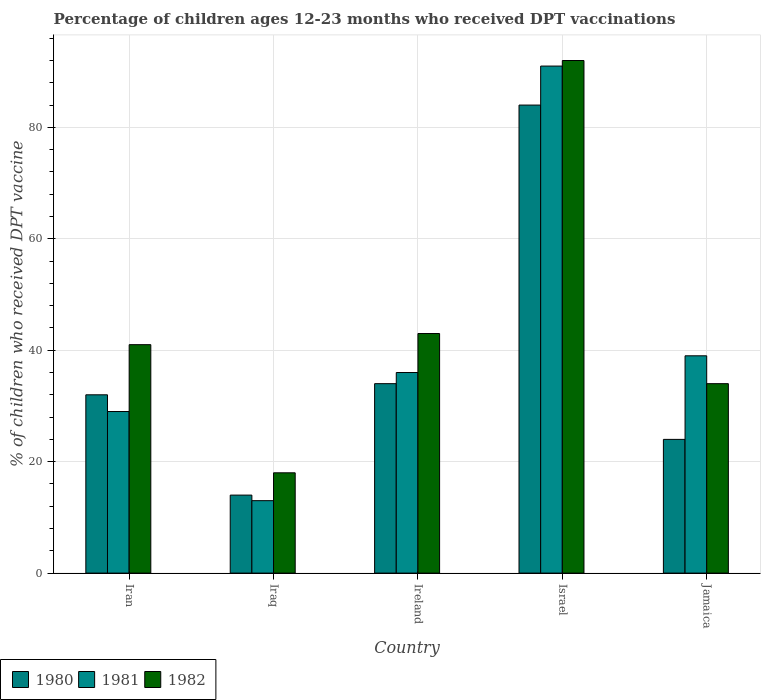Are the number of bars on each tick of the X-axis equal?
Provide a short and direct response. Yes. How many bars are there on the 3rd tick from the left?
Keep it short and to the point. 3. How many bars are there on the 4th tick from the right?
Offer a very short reply. 3. What is the label of the 4th group of bars from the left?
Your answer should be very brief. Israel. Across all countries, what is the maximum percentage of children who received DPT vaccination in 1981?
Offer a very short reply. 91. In which country was the percentage of children who received DPT vaccination in 1982 minimum?
Your answer should be very brief. Iraq. What is the total percentage of children who received DPT vaccination in 1980 in the graph?
Ensure brevity in your answer.  188. What is the difference between the percentage of children who received DPT vaccination in 1982 in Israel and that in Jamaica?
Provide a short and direct response. 58. What is the difference between the percentage of children who received DPT vaccination in 1981 in Jamaica and the percentage of children who received DPT vaccination in 1982 in Iraq?
Provide a succinct answer. 21. What is the average percentage of children who received DPT vaccination in 1980 per country?
Make the answer very short. 37.6. In how many countries, is the percentage of children who received DPT vaccination in 1981 greater than 28 %?
Your response must be concise. 4. What is the ratio of the percentage of children who received DPT vaccination in 1982 in Israel to that in Jamaica?
Ensure brevity in your answer.  2.71. Is the percentage of children who received DPT vaccination in 1982 in Iran less than that in Israel?
Offer a very short reply. Yes. What is the difference between the highest and the second highest percentage of children who received DPT vaccination in 1982?
Give a very brief answer. -2. What is the difference between the highest and the lowest percentage of children who received DPT vaccination in 1981?
Give a very brief answer. 78. Is the sum of the percentage of children who received DPT vaccination in 1982 in Iran and Jamaica greater than the maximum percentage of children who received DPT vaccination in 1981 across all countries?
Your response must be concise. No. What does the 3rd bar from the left in Iran represents?
Your answer should be compact. 1982. Are all the bars in the graph horizontal?
Give a very brief answer. No. What is the difference between two consecutive major ticks on the Y-axis?
Ensure brevity in your answer.  20. Are the values on the major ticks of Y-axis written in scientific E-notation?
Provide a short and direct response. No. Does the graph contain any zero values?
Make the answer very short. No. Does the graph contain grids?
Offer a very short reply. Yes. What is the title of the graph?
Offer a terse response. Percentage of children ages 12-23 months who received DPT vaccinations. Does "1966" appear as one of the legend labels in the graph?
Ensure brevity in your answer.  No. What is the label or title of the X-axis?
Offer a very short reply. Country. What is the label or title of the Y-axis?
Your answer should be very brief. % of children who received DPT vaccine. What is the % of children who received DPT vaccine of 1980 in Iran?
Provide a short and direct response. 32. What is the % of children who received DPT vaccine in 1981 in Iran?
Give a very brief answer. 29. What is the % of children who received DPT vaccine of 1980 in Iraq?
Offer a very short reply. 14. What is the % of children who received DPT vaccine of 1981 in Iraq?
Offer a very short reply. 13. What is the % of children who received DPT vaccine in 1981 in Ireland?
Offer a terse response. 36. What is the % of children who received DPT vaccine in 1981 in Israel?
Provide a short and direct response. 91. What is the % of children who received DPT vaccine in 1982 in Israel?
Offer a very short reply. 92. Across all countries, what is the maximum % of children who received DPT vaccine of 1980?
Your answer should be compact. 84. Across all countries, what is the maximum % of children who received DPT vaccine in 1981?
Your answer should be very brief. 91. Across all countries, what is the maximum % of children who received DPT vaccine of 1982?
Your answer should be very brief. 92. Across all countries, what is the minimum % of children who received DPT vaccine in 1980?
Your answer should be very brief. 14. Across all countries, what is the minimum % of children who received DPT vaccine of 1981?
Your response must be concise. 13. What is the total % of children who received DPT vaccine in 1980 in the graph?
Offer a terse response. 188. What is the total % of children who received DPT vaccine of 1981 in the graph?
Offer a very short reply. 208. What is the total % of children who received DPT vaccine of 1982 in the graph?
Provide a short and direct response. 228. What is the difference between the % of children who received DPT vaccine in 1981 in Iran and that in Iraq?
Give a very brief answer. 16. What is the difference between the % of children who received DPT vaccine in 1982 in Iran and that in Iraq?
Offer a very short reply. 23. What is the difference between the % of children who received DPT vaccine of 1980 in Iran and that in Israel?
Provide a succinct answer. -52. What is the difference between the % of children who received DPT vaccine in 1981 in Iran and that in Israel?
Your answer should be compact. -62. What is the difference between the % of children who received DPT vaccine in 1982 in Iran and that in Israel?
Give a very brief answer. -51. What is the difference between the % of children who received DPT vaccine of 1981 in Iran and that in Jamaica?
Give a very brief answer. -10. What is the difference between the % of children who received DPT vaccine of 1982 in Iran and that in Jamaica?
Ensure brevity in your answer.  7. What is the difference between the % of children who received DPT vaccine of 1980 in Iraq and that in Israel?
Your response must be concise. -70. What is the difference between the % of children who received DPT vaccine in 1981 in Iraq and that in Israel?
Provide a short and direct response. -78. What is the difference between the % of children who received DPT vaccine of 1982 in Iraq and that in Israel?
Keep it short and to the point. -74. What is the difference between the % of children who received DPT vaccine of 1981 in Ireland and that in Israel?
Ensure brevity in your answer.  -55. What is the difference between the % of children who received DPT vaccine of 1982 in Ireland and that in Israel?
Your response must be concise. -49. What is the difference between the % of children who received DPT vaccine of 1980 in Ireland and that in Jamaica?
Offer a terse response. 10. What is the difference between the % of children who received DPT vaccine in 1982 in Ireland and that in Jamaica?
Your answer should be compact. 9. What is the difference between the % of children who received DPT vaccine of 1981 in Israel and that in Jamaica?
Your response must be concise. 52. What is the difference between the % of children who received DPT vaccine of 1980 in Iran and the % of children who received DPT vaccine of 1981 in Iraq?
Offer a terse response. 19. What is the difference between the % of children who received DPT vaccine of 1980 in Iran and the % of children who received DPT vaccine of 1982 in Iraq?
Your answer should be very brief. 14. What is the difference between the % of children who received DPT vaccine of 1980 in Iran and the % of children who received DPT vaccine of 1982 in Ireland?
Offer a very short reply. -11. What is the difference between the % of children who received DPT vaccine of 1980 in Iran and the % of children who received DPT vaccine of 1981 in Israel?
Your answer should be very brief. -59. What is the difference between the % of children who received DPT vaccine of 1980 in Iran and the % of children who received DPT vaccine of 1982 in Israel?
Your answer should be compact. -60. What is the difference between the % of children who received DPT vaccine of 1981 in Iran and the % of children who received DPT vaccine of 1982 in Israel?
Ensure brevity in your answer.  -63. What is the difference between the % of children who received DPT vaccine of 1980 in Iran and the % of children who received DPT vaccine of 1981 in Jamaica?
Ensure brevity in your answer.  -7. What is the difference between the % of children who received DPT vaccine of 1981 in Iraq and the % of children who received DPT vaccine of 1982 in Ireland?
Your answer should be very brief. -30. What is the difference between the % of children who received DPT vaccine in 1980 in Iraq and the % of children who received DPT vaccine in 1981 in Israel?
Offer a very short reply. -77. What is the difference between the % of children who received DPT vaccine in 1980 in Iraq and the % of children who received DPT vaccine in 1982 in Israel?
Your response must be concise. -78. What is the difference between the % of children who received DPT vaccine in 1981 in Iraq and the % of children who received DPT vaccine in 1982 in Israel?
Offer a terse response. -79. What is the difference between the % of children who received DPT vaccine of 1980 in Iraq and the % of children who received DPT vaccine of 1982 in Jamaica?
Offer a very short reply. -20. What is the difference between the % of children who received DPT vaccine in 1980 in Ireland and the % of children who received DPT vaccine in 1981 in Israel?
Keep it short and to the point. -57. What is the difference between the % of children who received DPT vaccine of 1980 in Ireland and the % of children who received DPT vaccine of 1982 in Israel?
Your answer should be very brief. -58. What is the difference between the % of children who received DPT vaccine of 1981 in Ireland and the % of children who received DPT vaccine of 1982 in Israel?
Ensure brevity in your answer.  -56. What is the difference between the % of children who received DPT vaccine in 1980 in Ireland and the % of children who received DPT vaccine in 1981 in Jamaica?
Your answer should be very brief. -5. What is the difference between the % of children who received DPT vaccine of 1981 in Ireland and the % of children who received DPT vaccine of 1982 in Jamaica?
Provide a succinct answer. 2. What is the difference between the % of children who received DPT vaccine of 1980 in Israel and the % of children who received DPT vaccine of 1981 in Jamaica?
Provide a succinct answer. 45. What is the average % of children who received DPT vaccine in 1980 per country?
Offer a terse response. 37.6. What is the average % of children who received DPT vaccine in 1981 per country?
Your response must be concise. 41.6. What is the average % of children who received DPT vaccine in 1982 per country?
Your response must be concise. 45.6. What is the difference between the % of children who received DPT vaccine in 1980 and % of children who received DPT vaccine in 1981 in Iran?
Make the answer very short. 3. What is the difference between the % of children who received DPT vaccine of 1981 and % of children who received DPT vaccine of 1982 in Iran?
Offer a terse response. -12. What is the difference between the % of children who received DPT vaccine of 1980 and % of children who received DPT vaccine of 1981 in Iraq?
Your answer should be compact. 1. What is the difference between the % of children who received DPT vaccine in 1980 and % of children who received DPT vaccine in 1982 in Iraq?
Your answer should be very brief. -4. What is the difference between the % of children who received DPT vaccine in 1981 and % of children who received DPT vaccine in 1982 in Ireland?
Provide a succinct answer. -7. What is the difference between the % of children who received DPT vaccine of 1980 and % of children who received DPT vaccine of 1982 in Israel?
Your response must be concise. -8. What is the ratio of the % of children who received DPT vaccine of 1980 in Iran to that in Iraq?
Your answer should be very brief. 2.29. What is the ratio of the % of children who received DPT vaccine of 1981 in Iran to that in Iraq?
Provide a short and direct response. 2.23. What is the ratio of the % of children who received DPT vaccine in 1982 in Iran to that in Iraq?
Keep it short and to the point. 2.28. What is the ratio of the % of children who received DPT vaccine in 1981 in Iran to that in Ireland?
Offer a very short reply. 0.81. What is the ratio of the % of children who received DPT vaccine of 1982 in Iran to that in Ireland?
Your answer should be compact. 0.95. What is the ratio of the % of children who received DPT vaccine in 1980 in Iran to that in Israel?
Provide a short and direct response. 0.38. What is the ratio of the % of children who received DPT vaccine in 1981 in Iran to that in Israel?
Ensure brevity in your answer.  0.32. What is the ratio of the % of children who received DPT vaccine of 1982 in Iran to that in Israel?
Ensure brevity in your answer.  0.45. What is the ratio of the % of children who received DPT vaccine in 1981 in Iran to that in Jamaica?
Offer a very short reply. 0.74. What is the ratio of the % of children who received DPT vaccine of 1982 in Iran to that in Jamaica?
Provide a short and direct response. 1.21. What is the ratio of the % of children who received DPT vaccine in 1980 in Iraq to that in Ireland?
Make the answer very short. 0.41. What is the ratio of the % of children who received DPT vaccine in 1981 in Iraq to that in Ireland?
Your answer should be very brief. 0.36. What is the ratio of the % of children who received DPT vaccine of 1982 in Iraq to that in Ireland?
Provide a succinct answer. 0.42. What is the ratio of the % of children who received DPT vaccine of 1981 in Iraq to that in Israel?
Provide a succinct answer. 0.14. What is the ratio of the % of children who received DPT vaccine of 1982 in Iraq to that in Israel?
Your answer should be very brief. 0.2. What is the ratio of the % of children who received DPT vaccine in 1980 in Iraq to that in Jamaica?
Offer a very short reply. 0.58. What is the ratio of the % of children who received DPT vaccine of 1981 in Iraq to that in Jamaica?
Make the answer very short. 0.33. What is the ratio of the % of children who received DPT vaccine of 1982 in Iraq to that in Jamaica?
Offer a very short reply. 0.53. What is the ratio of the % of children who received DPT vaccine in 1980 in Ireland to that in Israel?
Offer a terse response. 0.4. What is the ratio of the % of children who received DPT vaccine in 1981 in Ireland to that in Israel?
Give a very brief answer. 0.4. What is the ratio of the % of children who received DPT vaccine in 1982 in Ireland to that in Israel?
Provide a succinct answer. 0.47. What is the ratio of the % of children who received DPT vaccine in 1980 in Ireland to that in Jamaica?
Offer a very short reply. 1.42. What is the ratio of the % of children who received DPT vaccine of 1982 in Ireland to that in Jamaica?
Make the answer very short. 1.26. What is the ratio of the % of children who received DPT vaccine in 1980 in Israel to that in Jamaica?
Your answer should be compact. 3.5. What is the ratio of the % of children who received DPT vaccine of 1981 in Israel to that in Jamaica?
Provide a succinct answer. 2.33. What is the ratio of the % of children who received DPT vaccine in 1982 in Israel to that in Jamaica?
Provide a short and direct response. 2.71. What is the difference between the highest and the second highest % of children who received DPT vaccine of 1980?
Make the answer very short. 50. What is the difference between the highest and the lowest % of children who received DPT vaccine in 1981?
Provide a succinct answer. 78. 